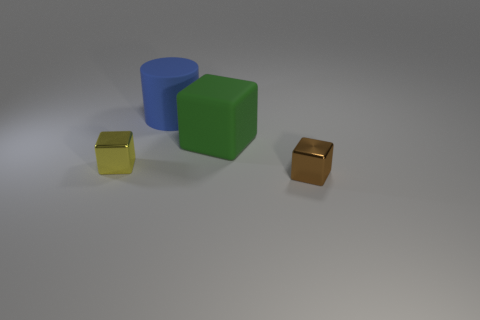Add 4 small yellow rubber cylinders. How many objects exist? 8 Subtract all blocks. How many objects are left? 1 Add 3 blue rubber objects. How many blue rubber objects exist? 4 Subtract 0 red cylinders. How many objects are left? 4 Subtract all rubber cylinders. Subtract all blue metallic balls. How many objects are left? 3 Add 4 brown objects. How many brown objects are left? 5 